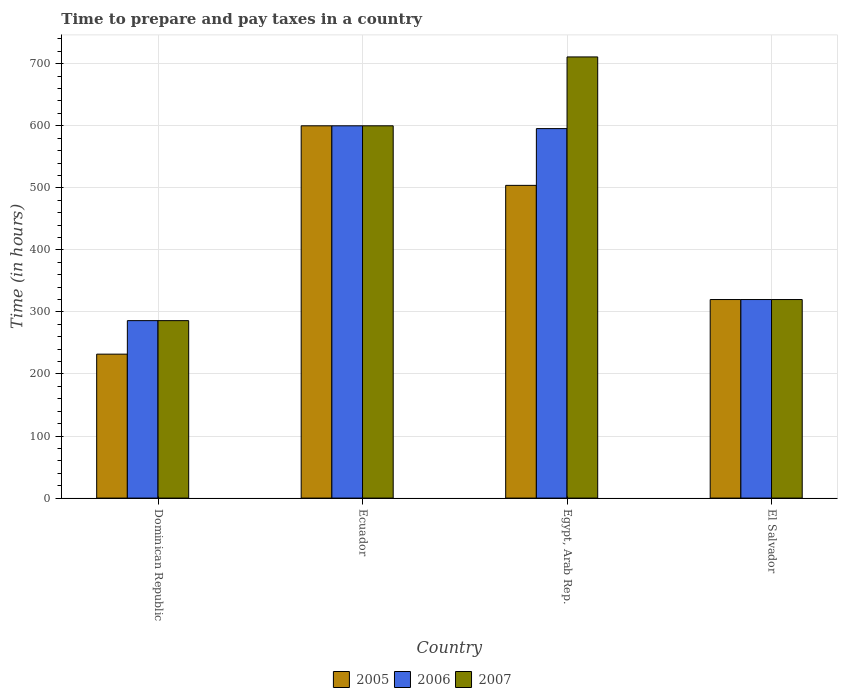Are the number of bars per tick equal to the number of legend labels?
Make the answer very short. Yes. What is the label of the 2nd group of bars from the left?
Your response must be concise. Ecuador. What is the number of hours required to prepare and pay taxes in 2007 in Egypt, Arab Rep.?
Your answer should be compact. 711. Across all countries, what is the maximum number of hours required to prepare and pay taxes in 2007?
Ensure brevity in your answer.  711. Across all countries, what is the minimum number of hours required to prepare and pay taxes in 2005?
Give a very brief answer. 232. In which country was the number of hours required to prepare and pay taxes in 2005 maximum?
Your answer should be compact. Ecuador. In which country was the number of hours required to prepare and pay taxes in 2005 minimum?
Your answer should be very brief. Dominican Republic. What is the total number of hours required to prepare and pay taxes in 2007 in the graph?
Your response must be concise. 1917. What is the difference between the number of hours required to prepare and pay taxes in 2007 in Dominican Republic and that in El Salvador?
Your answer should be very brief. -34. What is the difference between the number of hours required to prepare and pay taxes in 2005 in Ecuador and the number of hours required to prepare and pay taxes in 2007 in Dominican Republic?
Your answer should be compact. 314. What is the average number of hours required to prepare and pay taxes in 2005 per country?
Provide a short and direct response. 414. What is the difference between the number of hours required to prepare and pay taxes of/in 2007 and number of hours required to prepare and pay taxes of/in 2005 in Egypt, Arab Rep.?
Your answer should be very brief. 207. In how many countries, is the number of hours required to prepare and pay taxes in 2007 greater than 160 hours?
Make the answer very short. 4. What is the ratio of the number of hours required to prepare and pay taxes in 2005 in Egypt, Arab Rep. to that in El Salvador?
Your response must be concise. 1.57. Is the number of hours required to prepare and pay taxes in 2007 in Egypt, Arab Rep. less than that in El Salvador?
Provide a succinct answer. No. What is the difference between the highest and the second highest number of hours required to prepare and pay taxes in 2006?
Your answer should be very brief. 280. What is the difference between the highest and the lowest number of hours required to prepare and pay taxes in 2005?
Your response must be concise. 368. Is the sum of the number of hours required to prepare and pay taxes in 2006 in Ecuador and Egypt, Arab Rep. greater than the maximum number of hours required to prepare and pay taxes in 2005 across all countries?
Give a very brief answer. Yes. What does the 2nd bar from the right in Egypt, Arab Rep. represents?
Provide a succinct answer. 2006. Are all the bars in the graph horizontal?
Your answer should be very brief. No. Are the values on the major ticks of Y-axis written in scientific E-notation?
Provide a short and direct response. No. Does the graph contain grids?
Keep it short and to the point. Yes. What is the title of the graph?
Your answer should be compact. Time to prepare and pay taxes in a country. Does "2012" appear as one of the legend labels in the graph?
Provide a short and direct response. No. What is the label or title of the Y-axis?
Provide a succinct answer. Time (in hours). What is the Time (in hours) in 2005 in Dominican Republic?
Your answer should be compact. 232. What is the Time (in hours) in 2006 in Dominican Republic?
Ensure brevity in your answer.  286. What is the Time (in hours) in 2007 in Dominican Republic?
Your answer should be very brief. 286. What is the Time (in hours) of 2005 in Ecuador?
Give a very brief answer. 600. What is the Time (in hours) in 2006 in Ecuador?
Offer a terse response. 600. What is the Time (in hours) of 2007 in Ecuador?
Provide a short and direct response. 600. What is the Time (in hours) in 2005 in Egypt, Arab Rep.?
Your response must be concise. 504. What is the Time (in hours) of 2006 in Egypt, Arab Rep.?
Offer a very short reply. 595.5. What is the Time (in hours) of 2007 in Egypt, Arab Rep.?
Offer a very short reply. 711. What is the Time (in hours) of 2005 in El Salvador?
Your answer should be compact. 320. What is the Time (in hours) of 2006 in El Salvador?
Make the answer very short. 320. What is the Time (in hours) in 2007 in El Salvador?
Your response must be concise. 320. Across all countries, what is the maximum Time (in hours) of 2005?
Your response must be concise. 600. Across all countries, what is the maximum Time (in hours) of 2006?
Your response must be concise. 600. Across all countries, what is the maximum Time (in hours) in 2007?
Make the answer very short. 711. Across all countries, what is the minimum Time (in hours) of 2005?
Ensure brevity in your answer.  232. Across all countries, what is the minimum Time (in hours) in 2006?
Keep it short and to the point. 286. Across all countries, what is the minimum Time (in hours) in 2007?
Provide a succinct answer. 286. What is the total Time (in hours) in 2005 in the graph?
Provide a short and direct response. 1656. What is the total Time (in hours) in 2006 in the graph?
Make the answer very short. 1801.5. What is the total Time (in hours) in 2007 in the graph?
Offer a very short reply. 1917. What is the difference between the Time (in hours) of 2005 in Dominican Republic and that in Ecuador?
Your answer should be compact. -368. What is the difference between the Time (in hours) in 2006 in Dominican Republic and that in Ecuador?
Keep it short and to the point. -314. What is the difference between the Time (in hours) of 2007 in Dominican Republic and that in Ecuador?
Offer a very short reply. -314. What is the difference between the Time (in hours) in 2005 in Dominican Republic and that in Egypt, Arab Rep.?
Your answer should be very brief. -272. What is the difference between the Time (in hours) of 2006 in Dominican Republic and that in Egypt, Arab Rep.?
Your answer should be very brief. -309.5. What is the difference between the Time (in hours) in 2007 in Dominican Republic and that in Egypt, Arab Rep.?
Your response must be concise. -425. What is the difference between the Time (in hours) of 2005 in Dominican Republic and that in El Salvador?
Make the answer very short. -88. What is the difference between the Time (in hours) in 2006 in Dominican Republic and that in El Salvador?
Ensure brevity in your answer.  -34. What is the difference between the Time (in hours) in 2007 in Dominican Republic and that in El Salvador?
Offer a terse response. -34. What is the difference between the Time (in hours) of 2005 in Ecuador and that in Egypt, Arab Rep.?
Provide a short and direct response. 96. What is the difference between the Time (in hours) in 2006 in Ecuador and that in Egypt, Arab Rep.?
Your response must be concise. 4.5. What is the difference between the Time (in hours) in 2007 in Ecuador and that in Egypt, Arab Rep.?
Provide a succinct answer. -111. What is the difference between the Time (in hours) of 2005 in Ecuador and that in El Salvador?
Give a very brief answer. 280. What is the difference between the Time (in hours) of 2006 in Ecuador and that in El Salvador?
Ensure brevity in your answer.  280. What is the difference between the Time (in hours) of 2007 in Ecuador and that in El Salvador?
Give a very brief answer. 280. What is the difference between the Time (in hours) of 2005 in Egypt, Arab Rep. and that in El Salvador?
Ensure brevity in your answer.  184. What is the difference between the Time (in hours) in 2006 in Egypt, Arab Rep. and that in El Salvador?
Offer a very short reply. 275.5. What is the difference between the Time (in hours) of 2007 in Egypt, Arab Rep. and that in El Salvador?
Keep it short and to the point. 391. What is the difference between the Time (in hours) in 2005 in Dominican Republic and the Time (in hours) in 2006 in Ecuador?
Offer a terse response. -368. What is the difference between the Time (in hours) in 2005 in Dominican Republic and the Time (in hours) in 2007 in Ecuador?
Your answer should be compact. -368. What is the difference between the Time (in hours) in 2006 in Dominican Republic and the Time (in hours) in 2007 in Ecuador?
Provide a short and direct response. -314. What is the difference between the Time (in hours) of 2005 in Dominican Republic and the Time (in hours) of 2006 in Egypt, Arab Rep.?
Your response must be concise. -363.5. What is the difference between the Time (in hours) of 2005 in Dominican Republic and the Time (in hours) of 2007 in Egypt, Arab Rep.?
Provide a succinct answer. -479. What is the difference between the Time (in hours) of 2006 in Dominican Republic and the Time (in hours) of 2007 in Egypt, Arab Rep.?
Make the answer very short. -425. What is the difference between the Time (in hours) of 2005 in Dominican Republic and the Time (in hours) of 2006 in El Salvador?
Ensure brevity in your answer.  -88. What is the difference between the Time (in hours) of 2005 in Dominican Republic and the Time (in hours) of 2007 in El Salvador?
Your answer should be very brief. -88. What is the difference between the Time (in hours) in 2006 in Dominican Republic and the Time (in hours) in 2007 in El Salvador?
Provide a short and direct response. -34. What is the difference between the Time (in hours) in 2005 in Ecuador and the Time (in hours) in 2006 in Egypt, Arab Rep.?
Your answer should be compact. 4.5. What is the difference between the Time (in hours) of 2005 in Ecuador and the Time (in hours) of 2007 in Egypt, Arab Rep.?
Your response must be concise. -111. What is the difference between the Time (in hours) of 2006 in Ecuador and the Time (in hours) of 2007 in Egypt, Arab Rep.?
Provide a succinct answer. -111. What is the difference between the Time (in hours) of 2005 in Ecuador and the Time (in hours) of 2006 in El Salvador?
Keep it short and to the point. 280. What is the difference between the Time (in hours) of 2005 in Ecuador and the Time (in hours) of 2007 in El Salvador?
Offer a very short reply. 280. What is the difference between the Time (in hours) in 2006 in Ecuador and the Time (in hours) in 2007 in El Salvador?
Your answer should be compact. 280. What is the difference between the Time (in hours) of 2005 in Egypt, Arab Rep. and the Time (in hours) of 2006 in El Salvador?
Offer a very short reply. 184. What is the difference between the Time (in hours) of 2005 in Egypt, Arab Rep. and the Time (in hours) of 2007 in El Salvador?
Provide a succinct answer. 184. What is the difference between the Time (in hours) in 2006 in Egypt, Arab Rep. and the Time (in hours) in 2007 in El Salvador?
Provide a short and direct response. 275.5. What is the average Time (in hours) of 2005 per country?
Ensure brevity in your answer.  414. What is the average Time (in hours) in 2006 per country?
Make the answer very short. 450.38. What is the average Time (in hours) in 2007 per country?
Provide a succinct answer. 479.25. What is the difference between the Time (in hours) in 2005 and Time (in hours) in 2006 in Dominican Republic?
Offer a very short reply. -54. What is the difference between the Time (in hours) of 2005 and Time (in hours) of 2007 in Dominican Republic?
Ensure brevity in your answer.  -54. What is the difference between the Time (in hours) of 2006 and Time (in hours) of 2007 in Dominican Republic?
Provide a succinct answer. 0. What is the difference between the Time (in hours) of 2005 and Time (in hours) of 2006 in Egypt, Arab Rep.?
Provide a succinct answer. -91.5. What is the difference between the Time (in hours) in 2005 and Time (in hours) in 2007 in Egypt, Arab Rep.?
Ensure brevity in your answer.  -207. What is the difference between the Time (in hours) in 2006 and Time (in hours) in 2007 in Egypt, Arab Rep.?
Provide a succinct answer. -115.5. What is the difference between the Time (in hours) in 2005 and Time (in hours) in 2006 in El Salvador?
Provide a short and direct response. 0. What is the difference between the Time (in hours) in 2005 and Time (in hours) in 2007 in El Salvador?
Give a very brief answer. 0. What is the ratio of the Time (in hours) in 2005 in Dominican Republic to that in Ecuador?
Provide a short and direct response. 0.39. What is the ratio of the Time (in hours) in 2006 in Dominican Republic to that in Ecuador?
Offer a very short reply. 0.48. What is the ratio of the Time (in hours) of 2007 in Dominican Republic to that in Ecuador?
Give a very brief answer. 0.48. What is the ratio of the Time (in hours) of 2005 in Dominican Republic to that in Egypt, Arab Rep.?
Your response must be concise. 0.46. What is the ratio of the Time (in hours) in 2006 in Dominican Republic to that in Egypt, Arab Rep.?
Provide a succinct answer. 0.48. What is the ratio of the Time (in hours) in 2007 in Dominican Republic to that in Egypt, Arab Rep.?
Offer a very short reply. 0.4. What is the ratio of the Time (in hours) of 2005 in Dominican Republic to that in El Salvador?
Keep it short and to the point. 0.72. What is the ratio of the Time (in hours) in 2006 in Dominican Republic to that in El Salvador?
Keep it short and to the point. 0.89. What is the ratio of the Time (in hours) of 2007 in Dominican Republic to that in El Salvador?
Keep it short and to the point. 0.89. What is the ratio of the Time (in hours) in 2005 in Ecuador to that in Egypt, Arab Rep.?
Your answer should be very brief. 1.19. What is the ratio of the Time (in hours) of 2006 in Ecuador to that in Egypt, Arab Rep.?
Provide a short and direct response. 1.01. What is the ratio of the Time (in hours) in 2007 in Ecuador to that in Egypt, Arab Rep.?
Ensure brevity in your answer.  0.84. What is the ratio of the Time (in hours) in 2005 in Ecuador to that in El Salvador?
Ensure brevity in your answer.  1.88. What is the ratio of the Time (in hours) in 2006 in Ecuador to that in El Salvador?
Provide a succinct answer. 1.88. What is the ratio of the Time (in hours) in 2007 in Ecuador to that in El Salvador?
Your answer should be very brief. 1.88. What is the ratio of the Time (in hours) in 2005 in Egypt, Arab Rep. to that in El Salvador?
Offer a terse response. 1.57. What is the ratio of the Time (in hours) in 2006 in Egypt, Arab Rep. to that in El Salvador?
Your answer should be compact. 1.86. What is the ratio of the Time (in hours) of 2007 in Egypt, Arab Rep. to that in El Salvador?
Your response must be concise. 2.22. What is the difference between the highest and the second highest Time (in hours) of 2005?
Offer a terse response. 96. What is the difference between the highest and the second highest Time (in hours) of 2007?
Provide a short and direct response. 111. What is the difference between the highest and the lowest Time (in hours) in 2005?
Your response must be concise. 368. What is the difference between the highest and the lowest Time (in hours) in 2006?
Keep it short and to the point. 314. What is the difference between the highest and the lowest Time (in hours) in 2007?
Provide a short and direct response. 425. 